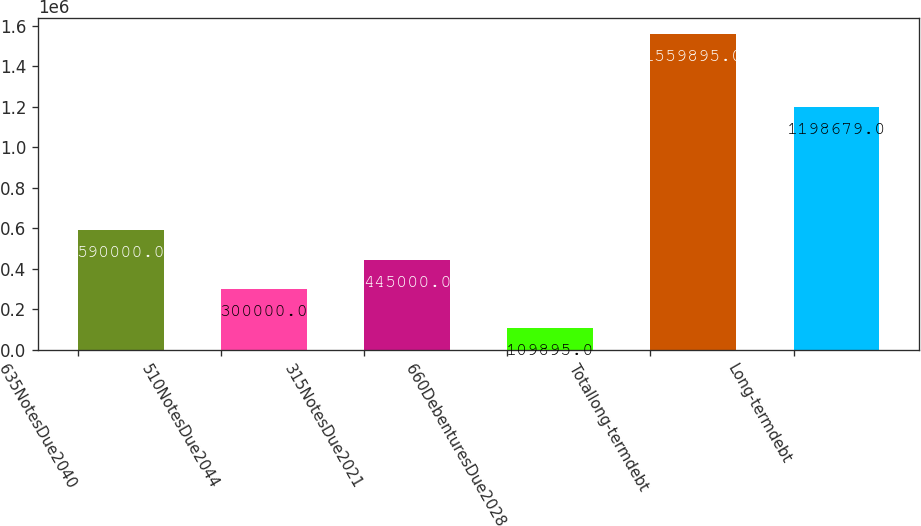Convert chart. <chart><loc_0><loc_0><loc_500><loc_500><bar_chart><fcel>635NotesDue2040<fcel>510NotesDue2044<fcel>315NotesDue2021<fcel>660DebenturesDue2028<fcel>Totallong-termdebt<fcel>Long-termdebt<nl><fcel>590000<fcel>300000<fcel>445000<fcel>109895<fcel>1.5599e+06<fcel>1.19868e+06<nl></chart> 